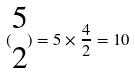Convert formula to latex. <formula><loc_0><loc_0><loc_500><loc_500>( \begin{matrix} 5 \\ 2 \end{matrix} ) = 5 \times \frac { 4 } { 2 } = 1 0</formula> 